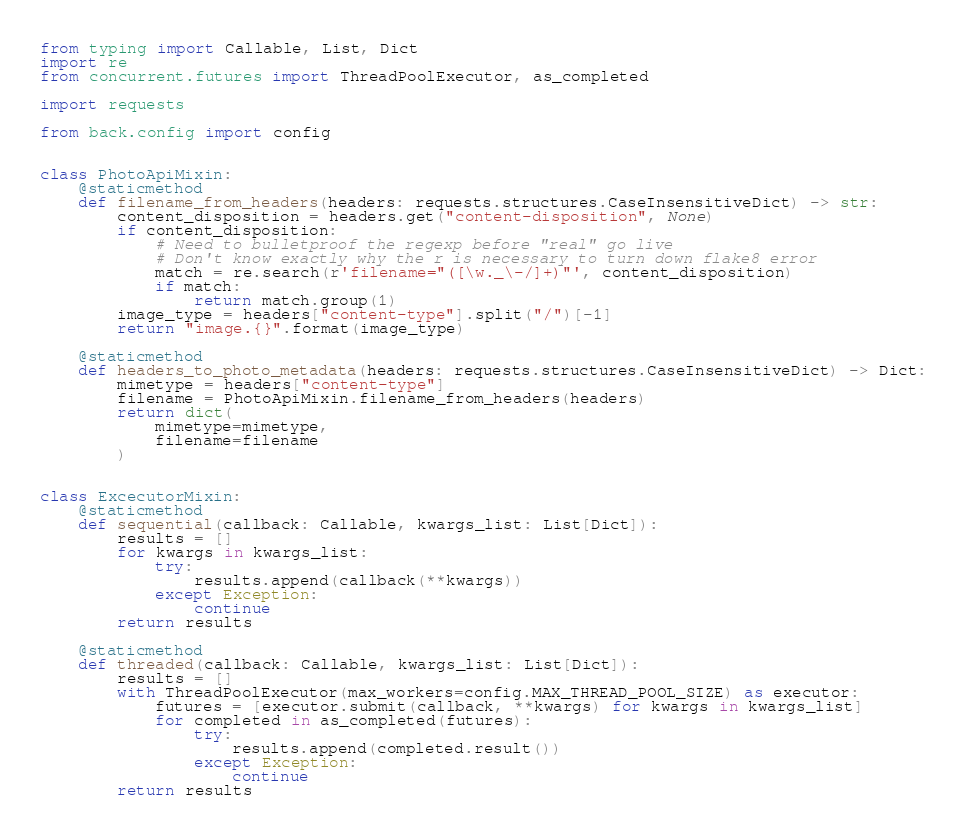<code> <loc_0><loc_0><loc_500><loc_500><_Python_>from typing import Callable, List, Dict
import re
from concurrent.futures import ThreadPoolExecutor, as_completed

import requests

from back.config import config


class PhotoApiMixin:
    @staticmethod
    def filename_from_headers(headers: requests.structures.CaseInsensitiveDict) -> str:
        content_disposition = headers.get("content-disposition", None)
        if content_disposition:
            # Need to bulletproof the regexp before "real" go live
            # Don't know exactly why the r is necessary to turn down flake8 error
            match = re.search(r'filename="([\w._\-/]+)"', content_disposition)
            if match:
                return match.group(1)
        image_type = headers["content-type"].split("/")[-1]
        return "image.{}".format(image_type)

    @staticmethod
    def headers_to_photo_metadata(headers: requests.structures.CaseInsensitiveDict) -> Dict:
        mimetype = headers["content-type"]
        filename = PhotoApiMixin.filename_from_headers(headers)
        return dict(
            mimetype=mimetype,
            filename=filename
        )


class ExcecutorMixin:
    @staticmethod
    def sequential(callback: Callable, kwargs_list: List[Dict]):
        results = []
        for kwargs in kwargs_list:
            try:
                results.append(callback(**kwargs))
            except Exception:
                continue
        return results

    @staticmethod
    def threaded(callback: Callable, kwargs_list: List[Dict]):
        results = []
        with ThreadPoolExecutor(max_workers=config.MAX_THREAD_POOL_SIZE) as executor:
            futures = [executor.submit(callback, **kwargs) for kwargs in kwargs_list]
            for completed in as_completed(futures):
                try:
                    results.append(completed.result())
                except Exception:
                    continue
        return results
</code> 